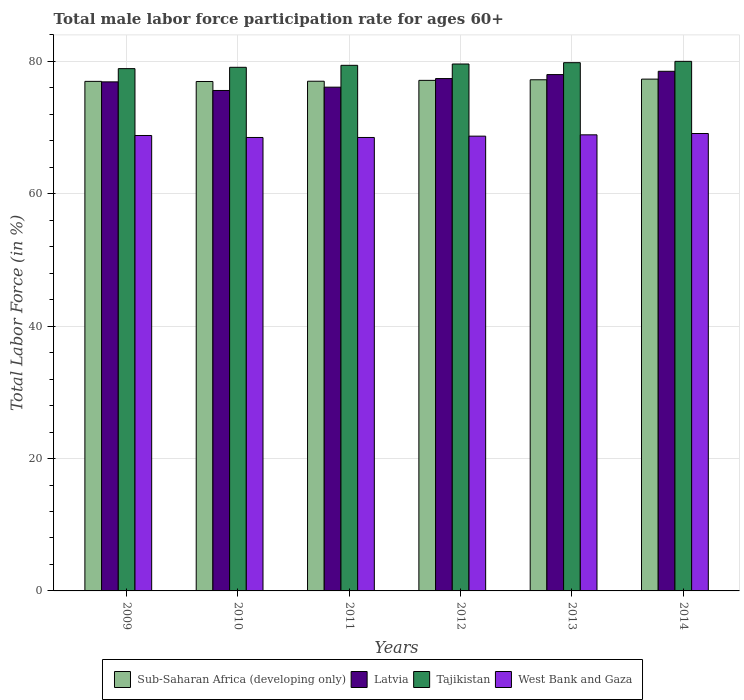How many different coloured bars are there?
Ensure brevity in your answer.  4. Are the number of bars on each tick of the X-axis equal?
Offer a terse response. Yes. How many bars are there on the 1st tick from the right?
Provide a succinct answer. 4. What is the male labor force participation rate in Latvia in 2014?
Your answer should be very brief. 78.5. Across all years, what is the maximum male labor force participation rate in West Bank and Gaza?
Provide a succinct answer. 69.1. Across all years, what is the minimum male labor force participation rate in Latvia?
Your response must be concise. 75.6. In which year was the male labor force participation rate in Latvia maximum?
Your answer should be very brief. 2014. What is the total male labor force participation rate in West Bank and Gaza in the graph?
Make the answer very short. 412.5. What is the difference between the male labor force participation rate in West Bank and Gaza in 2010 and that in 2013?
Keep it short and to the point. -0.4. What is the difference between the male labor force participation rate in Latvia in 2011 and the male labor force participation rate in Tajikistan in 2009?
Your response must be concise. -2.8. What is the average male labor force participation rate in Tajikistan per year?
Your response must be concise. 79.47. In the year 2010, what is the difference between the male labor force participation rate in Latvia and male labor force participation rate in Sub-Saharan Africa (developing only)?
Make the answer very short. -1.36. What is the ratio of the male labor force participation rate in Latvia in 2009 to that in 2013?
Offer a very short reply. 0.99. Is the male labor force participation rate in Latvia in 2013 less than that in 2014?
Provide a succinct answer. Yes. Is the difference between the male labor force participation rate in Latvia in 2009 and 2014 greater than the difference between the male labor force participation rate in Sub-Saharan Africa (developing only) in 2009 and 2014?
Offer a terse response. No. What is the difference between the highest and the second highest male labor force participation rate in Tajikistan?
Your answer should be compact. 0.2. What is the difference between the highest and the lowest male labor force participation rate in West Bank and Gaza?
Provide a succinct answer. 0.6. Is the sum of the male labor force participation rate in Latvia in 2012 and 2014 greater than the maximum male labor force participation rate in West Bank and Gaza across all years?
Make the answer very short. Yes. Is it the case that in every year, the sum of the male labor force participation rate in West Bank and Gaza and male labor force participation rate in Tajikistan is greater than the sum of male labor force participation rate in Latvia and male labor force participation rate in Sub-Saharan Africa (developing only)?
Make the answer very short. No. What does the 2nd bar from the left in 2014 represents?
Offer a terse response. Latvia. What does the 4th bar from the right in 2014 represents?
Your answer should be very brief. Sub-Saharan Africa (developing only). Is it the case that in every year, the sum of the male labor force participation rate in Sub-Saharan Africa (developing only) and male labor force participation rate in Tajikistan is greater than the male labor force participation rate in Latvia?
Your answer should be compact. Yes. Where does the legend appear in the graph?
Keep it short and to the point. Bottom center. How many legend labels are there?
Provide a succinct answer. 4. How are the legend labels stacked?
Ensure brevity in your answer.  Horizontal. What is the title of the graph?
Keep it short and to the point. Total male labor force participation rate for ages 60+. What is the label or title of the Y-axis?
Make the answer very short. Total Labor Force (in %). What is the Total Labor Force (in %) of Sub-Saharan Africa (developing only) in 2009?
Your response must be concise. 76.98. What is the Total Labor Force (in %) in Latvia in 2009?
Provide a succinct answer. 76.9. What is the Total Labor Force (in %) in Tajikistan in 2009?
Provide a short and direct response. 78.9. What is the Total Labor Force (in %) of West Bank and Gaza in 2009?
Make the answer very short. 68.8. What is the Total Labor Force (in %) of Sub-Saharan Africa (developing only) in 2010?
Your answer should be compact. 76.96. What is the Total Labor Force (in %) in Latvia in 2010?
Your answer should be very brief. 75.6. What is the Total Labor Force (in %) in Tajikistan in 2010?
Keep it short and to the point. 79.1. What is the Total Labor Force (in %) in West Bank and Gaza in 2010?
Give a very brief answer. 68.5. What is the Total Labor Force (in %) of Sub-Saharan Africa (developing only) in 2011?
Offer a terse response. 77. What is the Total Labor Force (in %) of Latvia in 2011?
Provide a succinct answer. 76.1. What is the Total Labor Force (in %) of Tajikistan in 2011?
Give a very brief answer. 79.4. What is the Total Labor Force (in %) in West Bank and Gaza in 2011?
Keep it short and to the point. 68.5. What is the Total Labor Force (in %) in Sub-Saharan Africa (developing only) in 2012?
Offer a terse response. 77.13. What is the Total Labor Force (in %) of Latvia in 2012?
Ensure brevity in your answer.  77.4. What is the Total Labor Force (in %) of Tajikistan in 2012?
Your answer should be very brief. 79.6. What is the Total Labor Force (in %) in West Bank and Gaza in 2012?
Your answer should be very brief. 68.7. What is the Total Labor Force (in %) of Sub-Saharan Africa (developing only) in 2013?
Make the answer very short. 77.22. What is the Total Labor Force (in %) of Latvia in 2013?
Ensure brevity in your answer.  78. What is the Total Labor Force (in %) of Tajikistan in 2013?
Your response must be concise. 79.8. What is the Total Labor Force (in %) in West Bank and Gaza in 2013?
Your answer should be very brief. 68.9. What is the Total Labor Force (in %) in Sub-Saharan Africa (developing only) in 2014?
Offer a terse response. 77.32. What is the Total Labor Force (in %) in Latvia in 2014?
Offer a terse response. 78.5. What is the Total Labor Force (in %) in West Bank and Gaza in 2014?
Make the answer very short. 69.1. Across all years, what is the maximum Total Labor Force (in %) of Sub-Saharan Africa (developing only)?
Keep it short and to the point. 77.32. Across all years, what is the maximum Total Labor Force (in %) in Latvia?
Your response must be concise. 78.5. Across all years, what is the maximum Total Labor Force (in %) of Tajikistan?
Ensure brevity in your answer.  80. Across all years, what is the maximum Total Labor Force (in %) of West Bank and Gaza?
Provide a short and direct response. 69.1. Across all years, what is the minimum Total Labor Force (in %) in Sub-Saharan Africa (developing only)?
Offer a very short reply. 76.96. Across all years, what is the minimum Total Labor Force (in %) in Latvia?
Keep it short and to the point. 75.6. Across all years, what is the minimum Total Labor Force (in %) of Tajikistan?
Give a very brief answer. 78.9. Across all years, what is the minimum Total Labor Force (in %) of West Bank and Gaza?
Your answer should be compact. 68.5. What is the total Total Labor Force (in %) in Sub-Saharan Africa (developing only) in the graph?
Keep it short and to the point. 462.59. What is the total Total Labor Force (in %) in Latvia in the graph?
Your answer should be compact. 462.5. What is the total Total Labor Force (in %) of Tajikistan in the graph?
Your answer should be compact. 476.8. What is the total Total Labor Force (in %) of West Bank and Gaza in the graph?
Provide a short and direct response. 412.5. What is the difference between the Total Labor Force (in %) of Sub-Saharan Africa (developing only) in 2009 and that in 2010?
Your response must be concise. 0.02. What is the difference between the Total Labor Force (in %) of Latvia in 2009 and that in 2010?
Your answer should be very brief. 1.3. What is the difference between the Total Labor Force (in %) of Tajikistan in 2009 and that in 2010?
Keep it short and to the point. -0.2. What is the difference between the Total Labor Force (in %) of Sub-Saharan Africa (developing only) in 2009 and that in 2011?
Your answer should be very brief. -0.02. What is the difference between the Total Labor Force (in %) in West Bank and Gaza in 2009 and that in 2011?
Your answer should be compact. 0.3. What is the difference between the Total Labor Force (in %) of Sub-Saharan Africa (developing only) in 2009 and that in 2012?
Your answer should be very brief. -0.15. What is the difference between the Total Labor Force (in %) in Tajikistan in 2009 and that in 2012?
Give a very brief answer. -0.7. What is the difference between the Total Labor Force (in %) of Sub-Saharan Africa (developing only) in 2009 and that in 2013?
Provide a succinct answer. -0.24. What is the difference between the Total Labor Force (in %) of Latvia in 2009 and that in 2013?
Your answer should be very brief. -1.1. What is the difference between the Total Labor Force (in %) of Sub-Saharan Africa (developing only) in 2009 and that in 2014?
Your answer should be compact. -0.34. What is the difference between the Total Labor Force (in %) of Tajikistan in 2009 and that in 2014?
Provide a succinct answer. -1.1. What is the difference between the Total Labor Force (in %) of Sub-Saharan Africa (developing only) in 2010 and that in 2011?
Your answer should be compact. -0.04. What is the difference between the Total Labor Force (in %) of Latvia in 2010 and that in 2011?
Your response must be concise. -0.5. What is the difference between the Total Labor Force (in %) in Sub-Saharan Africa (developing only) in 2010 and that in 2012?
Ensure brevity in your answer.  -0.17. What is the difference between the Total Labor Force (in %) of Tajikistan in 2010 and that in 2012?
Give a very brief answer. -0.5. What is the difference between the Total Labor Force (in %) in Sub-Saharan Africa (developing only) in 2010 and that in 2013?
Provide a short and direct response. -0.26. What is the difference between the Total Labor Force (in %) in Latvia in 2010 and that in 2013?
Provide a short and direct response. -2.4. What is the difference between the Total Labor Force (in %) of West Bank and Gaza in 2010 and that in 2013?
Provide a succinct answer. -0.4. What is the difference between the Total Labor Force (in %) of Sub-Saharan Africa (developing only) in 2010 and that in 2014?
Ensure brevity in your answer.  -0.36. What is the difference between the Total Labor Force (in %) in Latvia in 2010 and that in 2014?
Keep it short and to the point. -2.9. What is the difference between the Total Labor Force (in %) in Sub-Saharan Africa (developing only) in 2011 and that in 2012?
Offer a terse response. -0.13. What is the difference between the Total Labor Force (in %) of Latvia in 2011 and that in 2012?
Provide a succinct answer. -1.3. What is the difference between the Total Labor Force (in %) in Tajikistan in 2011 and that in 2012?
Offer a very short reply. -0.2. What is the difference between the Total Labor Force (in %) of West Bank and Gaza in 2011 and that in 2012?
Offer a very short reply. -0.2. What is the difference between the Total Labor Force (in %) in Sub-Saharan Africa (developing only) in 2011 and that in 2013?
Provide a succinct answer. -0.22. What is the difference between the Total Labor Force (in %) in West Bank and Gaza in 2011 and that in 2013?
Keep it short and to the point. -0.4. What is the difference between the Total Labor Force (in %) of Sub-Saharan Africa (developing only) in 2011 and that in 2014?
Offer a terse response. -0.32. What is the difference between the Total Labor Force (in %) in Latvia in 2011 and that in 2014?
Offer a very short reply. -2.4. What is the difference between the Total Labor Force (in %) of Tajikistan in 2011 and that in 2014?
Your answer should be compact. -0.6. What is the difference between the Total Labor Force (in %) in Sub-Saharan Africa (developing only) in 2012 and that in 2013?
Ensure brevity in your answer.  -0.09. What is the difference between the Total Labor Force (in %) of Sub-Saharan Africa (developing only) in 2012 and that in 2014?
Keep it short and to the point. -0.19. What is the difference between the Total Labor Force (in %) in Latvia in 2012 and that in 2014?
Offer a terse response. -1.1. What is the difference between the Total Labor Force (in %) of Sub-Saharan Africa (developing only) in 2013 and that in 2014?
Offer a terse response. -0.1. What is the difference between the Total Labor Force (in %) of Tajikistan in 2013 and that in 2014?
Your answer should be compact. -0.2. What is the difference between the Total Labor Force (in %) of Sub-Saharan Africa (developing only) in 2009 and the Total Labor Force (in %) of Latvia in 2010?
Your answer should be compact. 1.38. What is the difference between the Total Labor Force (in %) in Sub-Saharan Africa (developing only) in 2009 and the Total Labor Force (in %) in Tajikistan in 2010?
Provide a short and direct response. -2.12. What is the difference between the Total Labor Force (in %) in Sub-Saharan Africa (developing only) in 2009 and the Total Labor Force (in %) in West Bank and Gaza in 2010?
Provide a succinct answer. 8.48. What is the difference between the Total Labor Force (in %) of Latvia in 2009 and the Total Labor Force (in %) of Tajikistan in 2010?
Keep it short and to the point. -2.2. What is the difference between the Total Labor Force (in %) of Latvia in 2009 and the Total Labor Force (in %) of West Bank and Gaza in 2010?
Provide a succinct answer. 8.4. What is the difference between the Total Labor Force (in %) in Sub-Saharan Africa (developing only) in 2009 and the Total Labor Force (in %) in Latvia in 2011?
Your answer should be very brief. 0.88. What is the difference between the Total Labor Force (in %) of Sub-Saharan Africa (developing only) in 2009 and the Total Labor Force (in %) of Tajikistan in 2011?
Offer a very short reply. -2.42. What is the difference between the Total Labor Force (in %) in Sub-Saharan Africa (developing only) in 2009 and the Total Labor Force (in %) in West Bank and Gaza in 2011?
Provide a short and direct response. 8.48. What is the difference between the Total Labor Force (in %) in Latvia in 2009 and the Total Labor Force (in %) in Tajikistan in 2011?
Provide a succinct answer. -2.5. What is the difference between the Total Labor Force (in %) of Latvia in 2009 and the Total Labor Force (in %) of West Bank and Gaza in 2011?
Offer a very short reply. 8.4. What is the difference between the Total Labor Force (in %) of Tajikistan in 2009 and the Total Labor Force (in %) of West Bank and Gaza in 2011?
Your answer should be compact. 10.4. What is the difference between the Total Labor Force (in %) in Sub-Saharan Africa (developing only) in 2009 and the Total Labor Force (in %) in Latvia in 2012?
Offer a very short reply. -0.42. What is the difference between the Total Labor Force (in %) of Sub-Saharan Africa (developing only) in 2009 and the Total Labor Force (in %) of Tajikistan in 2012?
Ensure brevity in your answer.  -2.62. What is the difference between the Total Labor Force (in %) in Sub-Saharan Africa (developing only) in 2009 and the Total Labor Force (in %) in West Bank and Gaza in 2012?
Offer a very short reply. 8.28. What is the difference between the Total Labor Force (in %) in Tajikistan in 2009 and the Total Labor Force (in %) in West Bank and Gaza in 2012?
Offer a terse response. 10.2. What is the difference between the Total Labor Force (in %) in Sub-Saharan Africa (developing only) in 2009 and the Total Labor Force (in %) in Latvia in 2013?
Provide a succinct answer. -1.02. What is the difference between the Total Labor Force (in %) in Sub-Saharan Africa (developing only) in 2009 and the Total Labor Force (in %) in Tajikistan in 2013?
Provide a succinct answer. -2.82. What is the difference between the Total Labor Force (in %) in Sub-Saharan Africa (developing only) in 2009 and the Total Labor Force (in %) in West Bank and Gaza in 2013?
Provide a short and direct response. 8.08. What is the difference between the Total Labor Force (in %) in Tajikistan in 2009 and the Total Labor Force (in %) in West Bank and Gaza in 2013?
Provide a short and direct response. 10. What is the difference between the Total Labor Force (in %) in Sub-Saharan Africa (developing only) in 2009 and the Total Labor Force (in %) in Latvia in 2014?
Keep it short and to the point. -1.52. What is the difference between the Total Labor Force (in %) of Sub-Saharan Africa (developing only) in 2009 and the Total Labor Force (in %) of Tajikistan in 2014?
Offer a very short reply. -3.02. What is the difference between the Total Labor Force (in %) in Sub-Saharan Africa (developing only) in 2009 and the Total Labor Force (in %) in West Bank and Gaza in 2014?
Keep it short and to the point. 7.88. What is the difference between the Total Labor Force (in %) in Latvia in 2009 and the Total Labor Force (in %) in West Bank and Gaza in 2014?
Offer a terse response. 7.8. What is the difference between the Total Labor Force (in %) of Sub-Saharan Africa (developing only) in 2010 and the Total Labor Force (in %) of Latvia in 2011?
Give a very brief answer. 0.86. What is the difference between the Total Labor Force (in %) of Sub-Saharan Africa (developing only) in 2010 and the Total Labor Force (in %) of Tajikistan in 2011?
Offer a terse response. -2.44. What is the difference between the Total Labor Force (in %) of Sub-Saharan Africa (developing only) in 2010 and the Total Labor Force (in %) of West Bank and Gaza in 2011?
Give a very brief answer. 8.46. What is the difference between the Total Labor Force (in %) of Latvia in 2010 and the Total Labor Force (in %) of Tajikistan in 2011?
Your answer should be very brief. -3.8. What is the difference between the Total Labor Force (in %) of Sub-Saharan Africa (developing only) in 2010 and the Total Labor Force (in %) of Latvia in 2012?
Give a very brief answer. -0.44. What is the difference between the Total Labor Force (in %) of Sub-Saharan Africa (developing only) in 2010 and the Total Labor Force (in %) of Tajikistan in 2012?
Offer a terse response. -2.64. What is the difference between the Total Labor Force (in %) in Sub-Saharan Africa (developing only) in 2010 and the Total Labor Force (in %) in West Bank and Gaza in 2012?
Keep it short and to the point. 8.26. What is the difference between the Total Labor Force (in %) in Latvia in 2010 and the Total Labor Force (in %) in Tajikistan in 2012?
Give a very brief answer. -4. What is the difference between the Total Labor Force (in %) of Sub-Saharan Africa (developing only) in 2010 and the Total Labor Force (in %) of Latvia in 2013?
Offer a terse response. -1.04. What is the difference between the Total Labor Force (in %) in Sub-Saharan Africa (developing only) in 2010 and the Total Labor Force (in %) in Tajikistan in 2013?
Keep it short and to the point. -2.84. What is the difference between the Total Labor Force (in %) of Sub-Saharan Africa (developing only) in 2010 and the Total Labor Force (in %) of West Bank and Gaza in 2013?
Keep it short and to the point. 8.06. What is the difference between the Total Labor Force (in %) of Latvia in 2010 and the Total Labor Force (in %) of Tajikistan in 2013?
Make the answer very short. -4.2. What is the difference between the Total Labor Force (in %) in Latvia in 2010 and the Total Labor Force (in %) in West Bank and Gaza in 2013?
Make the answer very short. 6.7. What is the difference between the Total Labor Force (in %) in Tajikistan in 2010 and the Total Labor Force (in %) in West Bank and Gaza in 2013?
Provide a short and direct response. 10.2. What is the difference between the Total Labor Force (in %) in Sub-Saharan Africa (developing only) in 2010 and the Total Labor Force (in %) in Latvia in 2014?
Your answer should be very brief. -1.54. What is the difference between the Total Labor Force (in %) of Sub-Saharan Africa (developing only) in 2010 and the Total Labor Force (in %) of Tajikistan in 2014?
Make the answer very short. -3.04. What is the difference between the Total Labor Force (in %) of Sub-Saharan Africa (developing only) in 2010 and the Total Labor Force (in %) of West Bank and Gaza in 2014?
Provide a short and direct response. 7.86. What is the difference between the Total Labor Force (in %) of Tajikistan in 2010 and the Total Labor Force (in %) of West Bank and Gaza in 2014?
Your response must be concise. 10. What is the difference between the Total Labor Force (in %) in Sub-Saharan Africa (developing only) in 2011 and the Total Labor Force (in %) in Latvia in 2012?
Make the answer very short. -0.4. What is the difference between the Total Labor Force (in %) in Sub-Saharan Africa (developing only) in 2011 and the Total Labor Force (in %) in Tajikistan in 2012?
Your response must be concise. -2.6. What is the difference between the Total Labor Force (in %) in Sub-Saharan Africa (developing only) in 2011 and the Total Labor Force (in %) in West Bank and Gaza in 2012?
Offer a very short reply. 8.3. What is the difference between the Total Labor Force (in %) in Latvia in 2011 and the Total Labor Force (in %) in Tajikistan in 2012?
Your answer should be compact. -3.5. What is the difference between the Total Labor Force (in %) in Latvia in 2011 and the Total Labor Force (in %) in West Bank and Gaza in 2012?
Your answer should be compact. 7.4. What is the difference between the Total Labor Force (in %) of Tajikistan in 2011 and the Total Labor Force (in %) of West Bank and Gaza in 2012?
Offer a terse response. 10.7. What is the difference between the Total Labor Force (in %) in Sub-Saharan Africa (developing only) in 2011 and the Total Labor Force (in %) in Latvia in 2013?
Your answer should be very brief. -1. What is the difference between the Total Labor Force (in %) of Sub-Saharan Africa (developing only) in 2011 and the Total Labor Force (in %) of Tajikistan in 2013?
Offer a very short reply. -2.8. What is the difference between the Total Labor Force (in %) of Sub-Saharan Africa (developing only) in 2011 and the Total Labor Force (in %) of West Bank and Gaza in 2013?
Your answer should be compact. 8.1. What is the difference between the Total Labor Force (in %) of Latvia in 2011 and the Total Labor Force (in %) of Tajikistan in 2013?
Offer a very short reply. -3.7. What is the difference between the Total Labor Force (in %) of Sub-Saharan Africa (developing only) in 2011 and the Total Labor Force (in %) of Latvia in 2014?
Offer a terse response. -1.5. What is the difference between the Total Labor Force (in %) of Sub-Saharan Africa (developing only) in 2011 and the Total Labor Force (in %) of Tajikistan in 2014?
Keep it short and to the point. -3. What is the difference between the Total Labor Force (in %) of Sub-Saharan Africa (developing only) in 2011 and the Total Labor Force (in %) of West Bank and Gaza in 2014?
Give a very brief answer. 7.9. What is the difference between the Total Labor Force (in %) of Latvia in 2011 and the Total Labor Force (in %) of Tajikistan in 2014?
Make the answer very short. -3.9. What is the difference between the Total Labor Force (in %) in Sub-Saharan Africa (developing only) in 2012 and the Total Labor Force (in %) in Latvia in 2013?
Provide a succinct answer. -0.87. What is the difference between the Total Labor Force (in %) in Sub-Saharan Africa (developing only) in 2012 and the Total Labor Force (in %) in Tajikistan in 2013?
Provide a short and direct response. -2.67. What is the difference between the Total Labor Force (in %) of Sub-Saharan Africa (developing only) in 2012 and the Total Labor Force (in %) of West Bank and Gaza in 2013?
Provide a succinct answer. 8.23. What is the difference between the Total Labor Force (in %) in Latvia in 2012 and the Total Labor Force (in %) in Tajikistan in 2013?
Give a very brief answer. -2.4. What is the difference between the Total Labor Force (in %) in Sub-Saharan Africa (developing only) in 2012 and the Total Labor Force (in %) in Latvia in 2014?
Give a very brief answer. -1.37. What is the difference between the Total Labor Force (in %) of Sub-Saharan Africa (developing only) in 2012 and the Total Labor Force (in %) of Tajikistan in 2014?
Make the answer very short. -2.87. What is the difference between the Total Labor Force (in %) in Sub-Saharan Africa (developing only) in 2012 and the Total Labor Force (in %) in West Bank and Gaza in 2014?
Keep it short and to the point. 8.03. What is the difference between the Total Labor Force (in %) in Latvia in 2012 and the Total Labor Force (in %) in West Bank and Gaza in 2014?
Keep it short and to the point. 8.3. What is the difference between the Total Labor Force (in %) of Sub-Saharan Africa (developing only) in 2013 and the Total Labor Force (in %) of Latvia in 2014?
Provide a succinct answer. -1.28. What is the difference between the Total Labor Force (in %) in Sub-Saharan Africa (developing only) in 2013 and the Total Labor Force (in %) in Tajikistan in 2014?
Offer a very short reply. -2.78. What is the difference between the Total Labor Force (in %) of Sub-Saharan Africa (developing only) in 2013 and the Total Labor Force (in %) of West Bank and Gaza in 2014?
Offer a very short reply. 8.12. What is the difference between the Total Labor Force (in %) in Latvia in 2013 and the Total Labor Force (in %) in Tajikistan in 2014?
Make the answer very short. -2. What is the difference between the Total Labor Force (in %) of Latvia in 2013 and the Total Labor Force (in %) of West Bank and Gaza in 2014?
Provide a succinct answer. 8.9. What is the average Total Labor Force (in %) of Sub-Saharan Africa (developing only) per year?
Provide a short and direct response. 77.1. What is the average Total Labor Force (in %) in Latvia per year?
Give a very brief answer. 77.08. What is the average Total Labor Force (in %) of Tajikistan per year?
Give a very brief answer. 79.47. What is the average Total Labor Force (in %) of West Bank and Gaza per year?
Provide a short and direct response. 68.75. In the year 2009, what is the difference between the Total Labor Force (in %) of Sub-Saharan Africa (developing only) and Total Labor Force (in %) of Latvia?
Your response must be concise. 0.08. In the year 2009, what is the difference between the Total Labor Force (in %) of Sub-Saharan Africa (developing only) and Total Labor Force (in %) of Tajikistan?
Offer a terse response. -1.92. In the year 2009, what is the difference between the Total Labor Force (in %) of Sub-Saharan Africa (developing only) and Total Labor Force (in %) of West Bank and Gaza?
Offer a very short reply. 8.18. In the year 2009, what is the difference between the Total Labor Force (in %) of Latvia and Total Labor Force (in %) of West Bank and Gaza?
Your answer should be very brief. 8.1. In the year 2010, what is the difference between the Total Labor Force (in %) in Sub-Saharan Africa (developing only) and Total Labor Force (in %) in Latvia?
Give a very brief answer. 1.36. In the year 2010, what is the difference between the Total Labor Force (in %) of Sub-Saharan Africa (developing only) and Total Labor Force (in %) of Tajikistan?
Give a very brief answer. -2.14. In the year 2010, what is the difference between the Total Labor Force (in %) of Sub-Saharan Africa (developing only) and Total Labor Force (in %) of West Bank and Gaza?
Your answer should be compact. 8.46. In the year 2010, what is the difference between the Total Labor Force (in %) of Latvia and Total Labor Force (in %) of West Bank and Gaza?
Give a very brief answer. 7.1. In the year 2011, what is the difference between the Total Labor Force (in %) in Sub-Saharan Africa (developing only) and Total Labor Force (in %) in Latvia?
Provide a short and direct response. 0.9. In the year 2011, what is the difference between the Total Labor Force (in %) in Sub-Saharan Africa (developing only) and Total Labor Force (in %) in Tajikistan?
Your response must be concise. -2.4. In the year 2011, what is the difference between the Total Labor Force (in %) in Sub-Saharan Africa (developing only) and Total Labor Force (in %) in West Bank and Gaza?
Offer a terse response. 8.5. In the year 2011, what is the difference between the Total Labor Force (in %) of Latvia and Total Labor Force (in %) of Tajikistan?
Provide a succinct answer. -3.3. In the year 2011, what is the difference between the Total Labor Force (in %) of Tajikistan and Total Labor Force (in %) of West Bank and Gaza?
Ensure brevity in your answer.  10.9. In the year 2012, what is the difference between the Total Labor Force (in %) of Sub-Saharan Africa (developing only) and Total Labor Force (in %) of Latvia?
Make the answer very short. -0.27. In the year 2012, what is the difference between the Total Labor Force (in %) in Sub-Saharan Africa (developing only) and Total Labor Force (in %) in Tajikistan?
Offer a very short reply. -2.47. In the year 2012, what is the difference between the Total Labor Force (in %) of Sub-Saharan Africa (developing only) and Total Labor Force (in %) of West Bank and Gaza?
Make the answer very short. 8.43. In the year 2012, what is the difference between the Total Labor Force (in %) in Tajikistan and Total Labor Force (in %) in West Bank and Gaza?
Offer a terse response. 10.9. In the year 2013, what is the difference between the Total Labor Force (in %) in Sub-Saharan Africa (developing only) and Total Labor Force (in %) in Latvia?
Make the answer very short. -0.78. In the year 2013, what is the difference between the Total Labor Force (in %) of Sub-Saharan Africa (developing only) and Total Labor Force (in %) of Tajikistan?
Your response must be concise. -2.58. In the year 2013, what is the difference between the Total Labor Force (in %) of Sub-Saharan Africa (developing only) and Total Labor Force (in %) of West Bank and Gaza?
Make the answer very short. 8.32. In the year 2013, what is the difference between the Total Labor Force (in %) of Latvia and Total Labor Force (in %) of Tajikistan?
Keep it short and to the point. -1.8. In the year 2013, what is the difference between the Total Labor Force (in %) in Latvia and Total Labor Force (in %) in West Bank and Gaza?
Keep it short and to the point. 9.1. In the year 2013, what is the difference between the Total Labor Force (in %) in Tajikistan and Total Labor Force (in %) in West Bank and Gaza?
Offer a terse response. 10.9. In the year 2014, what is the difference between the Total Labor Force (in %) in Sub-Saharan Africa (developing only) and Total Labor Force (in %) in Latvia?
Offer a very short reply. -1.18. In the year 2014, what is the difference between the Total Labor Force (in %) in Sub-Saharan Africa (developing only) and Total Labor Force (in %) in Tajikistan?
Give a very brief answer. -2.68. In the year 2014, what is the difference between the Total Labor Force (in %) in Sub-Saharan Africa (developing only) and Total Labor Force (in %) in West Bank and Gaza?
Make the answer very short. 8.22. In the year 2014, what is the difference between the Total Labor Force (in %) in Latvia and Total Labor Force (in %) in Tajikistan?
Your answer should be compact. -1.5. In the year 2014, what is the difference between the Total Labor Force (in %) in Latvia and Total Labor Force (in %) in West Bank and Gaza?
Give a very brief answer. 9.4. What is the ratio of the Total Labor Force (in %) in Sub-Saharan Africa (developing only) in 2009 to that in 2010?
Make the answer very short. 1. What is the ratio of the Total Labor Force (in %) in Latvia in 2009 to that in 2010?
Offer a terse response. 1.02. What is the ratio of the Total Labor Force (in %) of Latvia in 2009 to that in 2011?
Your response must be concise. 1.01. What is the ratio of the Total Labor Force (in %) in Tajikistan in 2009 to that in 2011?
Provide a short and direct response. 0.99. What is the ratio of the Total Labor Force (in %) in West Bank and Gaza in 2009 to that in 2011?
Your answer should be compact. 1. What is the ratio of the Total Labor Force (in %) of Sub-Saharan Africa (developing only) in 2009 to that in 2012?
Offer a very short reply. 1. What is the ratio of the Total Labor Force (in %) in Tajikistan in 2009 to that in 2012?
Offer a very short reply. 0.99. What is the ratio of the Total Labor Force (in %) of West Bank and Gaza in 2009 to that in 2012?
Give a very brief answer. 1. What is the ratio of the Total Labor Force (in %) of Sub-Saharan Africa (developing only) in 2009 to that in 2013?
Provide a short and direct response. 1. What is the ratio of the Total Labor Force (in %) of Latvia in 2009 to that in 2013?
Your answer should be very brief. 0.99. What is the ratio of the Total Labor Force (in %) in Tajikistan in 2009 to that in 2013?
Your answer should be compact. 0.99. What is the ratio of the Total Labor Force (in %) in West Bank and Gaza in 2009 to that in 2013?
Your answer should be very brief. 1. What is the ratio of the Total Labor Force (in %) in Sub-Saharan Africa (developing only) in 2009 to that in 2014?
Provide a succinct answer. 1. What is the ratio of the Total Labor Force (in %) in Latvia in 2009 to that in 2014?
Your response must be concise. 0.98. What is the ratio of the Total Labor Force (in %) in Tajikistan in 2009 to that in 2014?
Offer a very short reply. 0.99. What is the ratio of the Total Labor Force (in %) of West Bank and Gaza in 2009 to that in 2014?
Your response must be concise. 1. What is the ratio of the Total Labor Force (in %) in Sub-Saharan Africa (developing only) in 2010 to that in 2011?
Ensure brevity in your answer.  1. What is the ratio of the Total Labor Force (in %) of Latvia in 2010 to that in 2011?
Offer a terse response. 0.99. What is the ratio of the Total Labor Force (in %) of Tajikistan in 2010 to that in 2011?
Offer a terse response. 1. What is the ratio of the Total Labor Force (in %) of Sub-Saharan Africa (developing only) in 2010 to that in 2012?
Offer a very short reply. 1. What is the ratio of the Total Labor Force (in %) in Latvia in 2010 to that in 2012?
Provide a succinct answer. 0.98. What is the ratio of the Total Labor Force (in %) in West Bank and Gaza in 2010 to that in 2012?
Give a very brief answer. 1. What is the ratio of the Total Labor Force (in %) of Latvia in 2010 to that in 2013?
Your answer should be compact. 0.97. What is the ratio of the Total Labor Force (in %) in West Bank and Gaza in 2010 to that in 2013?
Keep it short and to the point. 0.99. What is the ratio of the Total Labor Force (in %) in Sub-Saharan Africa (developing only) in 2010 to that in 2014?
Provide a short and direct response. 1. What is the ratio of the Total Labor Force (in %) of Latvia in 2010 to that in 2014?
Offer a terse response. 0.96. What is the ratio of the Total Labor Force (in %) of Tajikistan in 2010 to that in 2014?
Your response must be concise. 0.99. What is the ratio of the Total Labor Force (in %) in Latvia in 2011 to that in 2012?
Provide a succinct answer. 0.98. What is the ratio of the Total Labor Force (in %) in Tajikistan in 2011 to that in 2012?
Provide a succinct answer. 1. What is the ratio of the Total Labor Force (in %) in West Bank and Gaza in 2011 to that in 2012?
Make the answer very short. 1. What is the ratio of the Total Labor Force (in %) of Latvia in 2011 to that in 2013?
Your answer should be compact. 0.98. What is the ratio of the Total Labor Force (in %) in West Bank and Gaza in 2011 to that in 2013?
Provide a short and direct response. 0.99. What is the ratio of the Total Labor Force (in %) in Latvia in 2011 to that in 2014?
Your answer should be very brief. 0.97. What is the ratio of the Total Labor Force (in %) in Tajikistan in 2011 to that in 2014?
Ensure brevity in your answer.  0.99. What is the ratio of the Total Labor Force (in %) of West Bank and Gaza in 2012 to that in 2013?
Your answer should be very brief. 1. What is the ratio of the Total Labor Force (in %) of Sub-Saharan Africa (developing only) in 2012 to that in 2014?
Offer a terse response. 1. What is the ratio of the Total Labor Force (in %) in Latvia in 2012 to that in 2014?
Make the answer very short. 0.99. What is the ratio of the Total Labor Force (in %) in Tajikistan in 2012 to that in 2014?
Offer a very short reply. 0.99. What is the ratio of the Total Labor Force (in %) in West Bank and Gaza in 2012 to that in 2014?
Keep it short and to the point. 0.99. What is the ratio of the Total Labor Force (in %) of Sub-Saharan Africa (developing only) in 2013 to that in 2014?
Your response must be concise. 1. What is the ratio of the Total Labor Force (in %) of Tajikistan in 2013 to that in 2014?
Your answer should be compact. 1. What is the difference between the highest and the second highest Total Labor Force (in %) in Sub-Saharan Africa (developing only)?
Offer a very short reply. 0.1. What is the difference between the highest and the lowest Total Labor Force (in %) of Sub-Saharan Africa (developing only)?
Provide a short and direct response. 0.36. What is the difference between the highest and the lowest Total Labor Force (in %) in Latvia?
Your response must be concise. 2.9. 